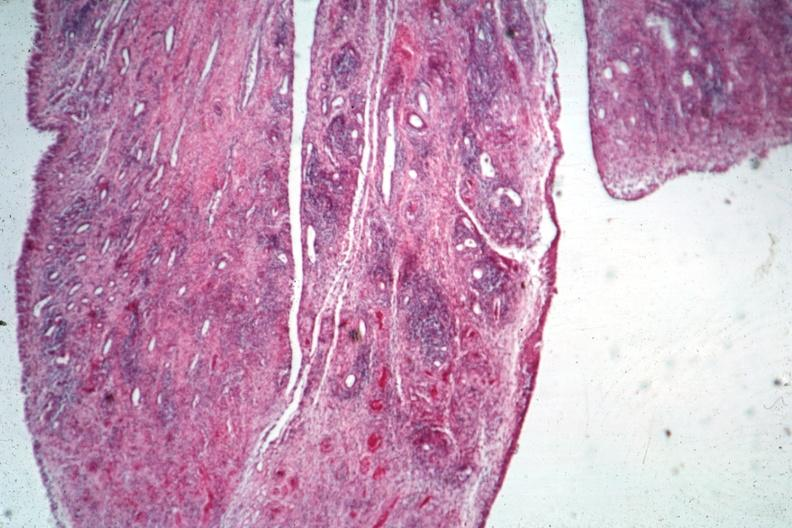does this image show typical lesion?
Answer the question using a single word or phrase. Yes 